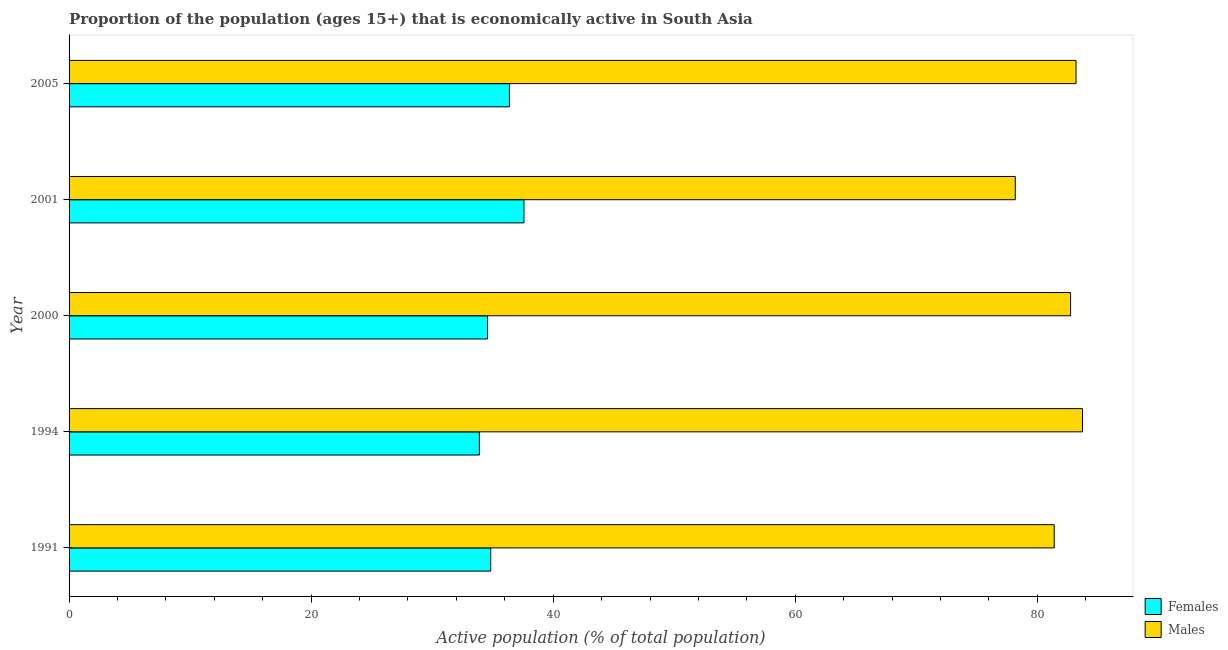Are the number of bars per tick equal to the number of legend labels?
Your response must be concise. Yes. What is the label of the 2nd group of bars from the top?
Provide a short and direct response. 2001. What is the percentage of economically active male population in 2000?
Your answer should be very brief. 82.74. Across all years, what is the maximum percentage of economically active female population?
Your answer should be compact. 37.58. Across all years, what is the minimum percentage of economically active female population?
Your answer should be compact. 33.9. In which year was the percentage of economically active female population minimum?
Provide a succinct answer. 1994. What is the total percentage of economically active female population in the graph?
Your answer should be very brief. 177.27. What is the difference between the percentage of economically active male population in 2001 and that in 2005?
Make the answer very short. -5.02. What is the difference between the percentage of economically active male population in 1991 and the percentage of economically active female population in 2001?
Your answer should be very brief. 43.81. What is the average percentage of economically active female population per year?
Give a very brief answer. 35.45. In the year 2000, what is the difference between the percentage of economically active male population and percentage of economically active female population?
Your answer should be compact. 48.17. In how many years, is the percentage of economically active male population greater than 8 %?
Make the answer very short. 5. What is the ratio of the percentage of economically active male population in 2000 to that in 2005?
Your response must be concise. 0.99. Is the percentage of economically active female population in 1991 less than that in 2001?
Provide a succinct answer. Yes. What is the difference between the highest and the second highest percentage of economically active male population?
Offer a very short reply. 0.53. What is the difference between the highest and the lowest percentage of economically active male population?
Your answer should be compact. 5.55. What does the 1st bar from the top in 1991 represents?
Your response must be concise. Males. What does the 2nd bar from the bottom in 2000 represents?
Your answer should be very brief. Males. How many bars are there?
Your answer should be very brief. 10. Does the graph contain grids?
Offer a terse response. No. How many legend labels are there?
Offer a terse response. 2. How are the legend labels stacked?
Provide a short and direct response. Vertical. What is the title of the graph?
Provide a short and direct response. Proportion of the population (ages 15+) that is economically active in South Asia. What is the label or title of the X-axis?
Give a very brief answer. Active population (% of total population). What is the Active population (% of total population) of Females in 1991?
Offer a very short reply. 34.84. What is the Active population (% of total population) in Males in 1991?
Provide a succinct answer. 81.39. What is the Active population (% of total population) in Females in 1994?
Offer a very short reply. 33.9. What is the Active population (% of total population) in Males in 1994?
Your answer should be very brief. 83.73. What is the Active population (% of total population) in Females in 2000?
Your answer should be compact. 34.57. What is the Active population (% of total population) in Males in 2000?
Make the answer very short. 82.74. What is the Active population (% of total population) of Females in 2001?
Ensure brevity in your answer.  37.58. What is the Active population (% of total population) in Males in 2001?
Offer a very short reply. 78.17. What is the Active population (% of total population) in Females in 2005?
Keep it short and to the point. 36.38. What is the Active population (% of total population) of Males in 2005?
Offer a terse response. 83.19. Across all years, what is the maximum Active population (% of total population) in Females?
Make the answer very short. 37.58. Across all years, what is the maximum Active population (% of total population) in Males?
Ensure brevity in your answer.  83.73. Across all years, what is the minimum Active population (% of total population) in Females?
Your response must be concise. 33.9. Across all years, what is the minimum Active population (% of total population) in Males?
Ensure brevity in your answer.  78.17. What is the total Active population (% of total population) of Females in the graph?
Provide a short and direct response. 177.27. What is the total Active population (% of total population) in Males in the graph?
Provide a succinct answer. 409.23. What is the difference between the Active population (% of total population) of Females in 1991 and that in 1994?
Provide a succinct answer. 0.94. What is the difference between the Active population (% of total population) in Males in 1991 and that in 1994?
Offer a terse response. -2.34. What is the difference between the Active population (% of total population) of Females in 1991 and that in 2000?
Offer a terse response. 0.27. What is the difference between the Active population (% of total population) of Males in 1991 and that in 2000?
Make the answer very short. -1.35. What is the difference between the Active population (% of total population) in Females in 1991 and that in 2001?
Make the answer very short. -2.75. What is the difference between the Active population (% of total population) in Males in 1991 and that in 2001?
Keep it short and to the point. 3.22. What is the difference between the Active population (% of total population) of Females in 1991 and that in 2005?
Provide a short and direct response. -1.55. What is the difference between the Active population (% of total population) in Males in 1991 and that in 2005?
Your answer should be compact. -1.8. What is the difference between the Active population (% of total population) in Females in 1994 and that in 2000?
Your response must be concise. -0.67. What is the difference between the Active population (% of total population) of Males in 1994 and that in 2000?
Keep it short and to the point. 0.98. What is the difference between the Active population (% of total population) in Females in 1994 and that in 2001?
Give a very brief answer. -3.68. What is the difference between the Active population (% of total population) in Males in 1994 and that in 2001?
Keep it short and to the point. 5.55. What is the difference between the Active population (% of total population) in Females in 1994 and that in 2005?
Provide a succinct answer. -2.48. What is the difference between the Active population (% of total population) of Males in 1994 and that in 2005?
Offer a very short reply. 0.53. What is the difference between the Active population (% of total population) in Females in 2000 and that in 2001?
Your answer should be compact. -3.01. What is the difference between the Active population (% of total population) of Males in 2000 and that in 2001?
Ensure brevity in your answer.  4.57. What is the difference between the Active population (% of total population) of Females in 2000 and that in 2005?
Give a very brief answer. -1.81. What is the difference between the Active population (% of total population) of Males in 2000 and that in 2005?
Offer a very short reply. -0.45. What is the difference between the Active population (% of total population) of Females in 2001 and that in 2005?
Your answer should be compact. 1.2. What is the difference between the Active population (% of total population) of Males in 2001 and that in 2005?
Offer a very short reply. -5.02. What is the difference between the Active population (% of total population) in Females in 1991 and the Active population (% of total population) in Males in 1994?
Your response must be concise. -48.89. What is the difference between the Active population (% of total population) in Females in 1991 and the Active population (% of total population) in Males in 2000?
Keep it short and to the point. -47.91. What is the difference between the Active population (% of total population) of Females in 1991 and the Active population (% of total population) of Males in 2001?
Give a very brief answer. -43.34. What is the difference between the Active population (% of total population) of Females in 1991 and the Active population (% of total population) of Males in 2005?
Offer a very short reply. -48.36. What is the difference between the Active population (% of total population) of Females in 1994 and the Active population (% of total population) of Males in 2000?
Ensure brevity in your answer.  -48.85. What is the difference between the Active population (% of total population) of Females in 1994 and the Active population (% of total population) of Males in 2001?
Your response must be concise. -44.28. What is the difference between the Active population (% of total population) of Females in 1994 and the Active population (% of total population) of Males in 2005?
Offer a terse response. -49.3. What is the difference between the Active population (% of total population) in Females in 2000 and the Active population (% of total population) in Males in 2001?
Your answer should be very brief. -43.6. What is the difference between the Active population (% of total population) of Females in 2000 and the Active population (% of total population) of Males in 2005?
Your answer should be very brief. -48.62. What is the difference between the Active population (% of total population) of Females in 2001 and the Active population (% of total population) of Males in 2005?
Your response must be concise. -45.61. What is the average Active population (% of total population) in Females per year?
Offer a terse response. 35.45. What is the average Active population (% of total population) in Males per year?
Your answer should be compact. 81.85. In the year 1991, what is the difference between the Active population (% of total population) in Females and Active population (% of total population) in Males?
Ensure brevity in your answer.  -46.55. In the year 1994, what is the difference between the Active population (% of total population) of Females and Active population (% of total population) of Males?
Ensure brevity in your answer.  -49.83. In the year 2000, what is the difference between the Active population (% of total population) of Females and Active population (% of total population) of Males?
Offer a terse response. -48.17. In the year 2001, what is the difference between the Active population (% of total population) in Females and Active population (% of total population) in Males?
Ensure brevity in your answer.  -40.59. In the year 2005, what is the difference between the Active population (% of total population) in Females and Active population (% of total population) in Males?
Make the answer very short. -46.81. What is the ratio of the Active population (% of total population) in Females in 1991 to that in 1994?
Provide a short and direct response. 1.03. What is the ratio of the Active population (% of total population) of Males in 1991 to that in 1994?
Offer a terse response. 0.97. What is the ratio of the Active population (% of total population) in Females in 1991 to that in 2000?
Your answer should be very brief. 1.01. What is the ratio of the Active population (% of total population) in Males in 1991 to that in 2000?
Your answer should be compact. 0.98. What is the ratio of the Active population (% of total population) of Females in 1991 to that in 2001?
Offer a terse response. 0.93. What is the ratio of the Active population (% of total population) of Males in 1991 to that in 2001?
Your response must be concise. 1.04. What is the ratio of the Active population (% of total population) in Females in 1991 to that in 2005?
Ensure brevity in your answer.  0.96. What is the ratio of the Active population (% of total population) of Males in 1991 to that in 2005?
Make the answer very short. 0.98. What is the ratio of the Active population (% of total population) in Females in 1994 to that in 2000?
Your response must be concise. 0.98. What is the ratio of the Active population (% of total population) in Males in 1994 to that in 2000?
Your answer should be very brief. 1.01. What is the ratio of the Active population (% of total population) in Females in 1994 to that in 2001?
Provide a succinct answer. 0.9. What is the ratio of the Active population (% of total population) in Males in 1994 to that in 2001?
Keep it short and to the point. 1.07. What is the ratio of the Active population (% of total population) of Females in 1994 to that in 2005?
Provide a short and direct response. 0.93. What is the ratio of the Active population (% of total population) in Males in 1994 to that in 2005?
Provide a succinct answer. 1.01. What is the ratio of the Active population (% of total population) of Females in 2000 to that in 2001?
Ensure brevity in your answer.  0.92. What is the ratio of the Active population (% of total population) in Males in 2000 to that in 2001?
Provide a short and direct response. 1.06. What is the ratio of the Active population (% of total population) of Females in 2000 to that in 2005?
Your answer should be very brief. 0.95. What is the ratio of the Active population (% of total population) in Males in 2000 to that in 2005?
Your response must be concise. 0.99. What is the ratio of the Active population (% of total population) of Females in 2001 to that in 2005?
Give a very brief answer. 1.03. What is the ratio of the Active population (% of total population) in Males in 2001 to that in 2005?
Give a very brief answer. 0.94. What is the difference between the highest and the second highest Active population (% of total population) of Females?
Give a very brief answer. 1.2. What is the difference between the highest and the second highest Active population (% of total population) in Males?
Make the answer very short. 0.53. What is the difference between the highest and the lowest Active population (% of total population) in Females?
Ensure brevity in your answer.  3.68. What is the difference between the highest and the lowest Active population (% of total population) of Males?
Your response must be concise. 5.55. 